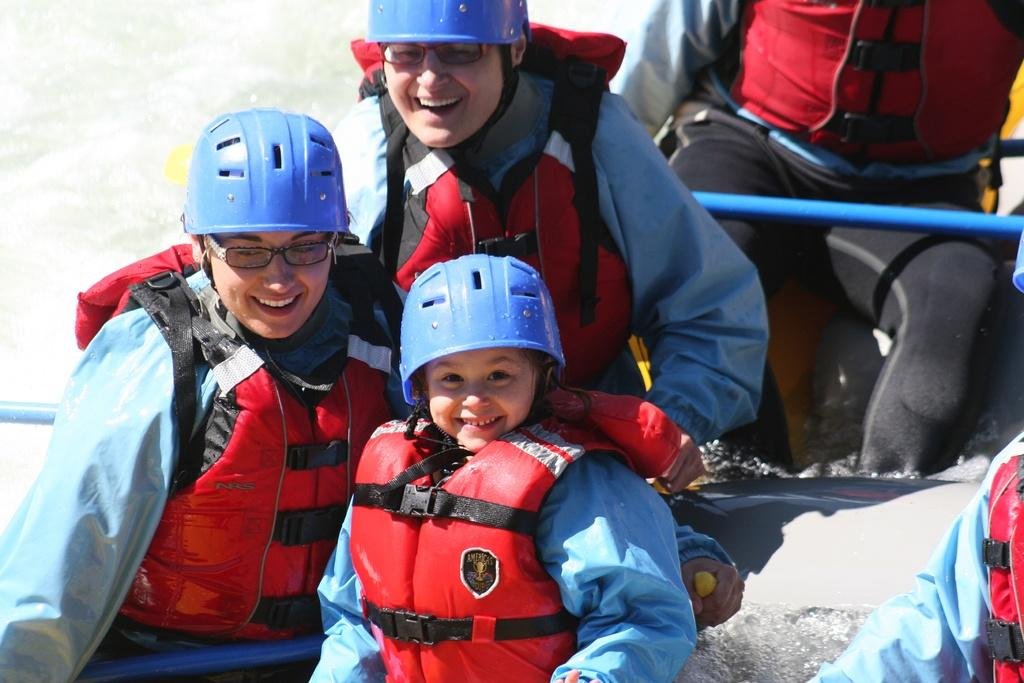Who is present in the image? There are people in the image. What are the people doing in the image? The people are sitting on a rafting boat. What safety equipment are the people wearing in the image? The people are wearing life jackets and helmets. What can be seen in the background of the image? There is water visible in the background of the image. How many children are playing with hope and a wing in the image? There are no children, hope, or wing present in the image. 